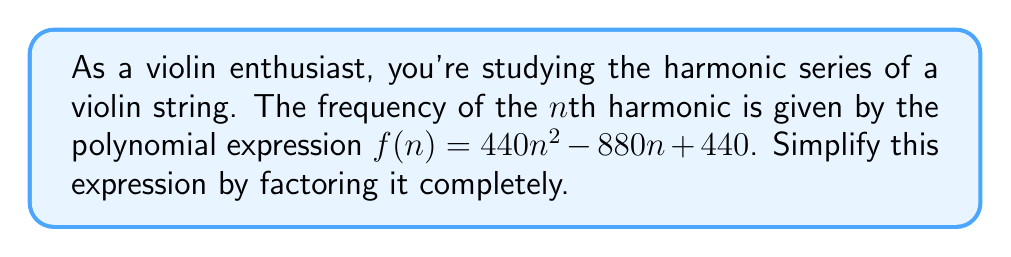Can you answer this question? Let's approach this step-by-step:

1) First, we recognize that this is a quadratic expression in the form $an^2 + bn + c$, where:
   $a = 440$
   $b = -880$
   $c = 440$

2) To factor this, we'll use the common factor method first:
   $f(n) = 440(n^2 - 2n + 1)$

3) Now, we focus on the expression inside the parentheses: $n^2 - 2n + 1$
   This is a perfect square trinomial in the form $(n - 1)^2$

4) Therefore, we can rewrite our expression as:
   $f(n) = 440(n - 1)^2$

5) This is now fully factored. We can interpret this musically:
   - 440 Hz is the frequency of A4 (the A above middle C)
   - $(n - 1)^2$ represents how the frequency changes for each harmonic

This simplified form shows that the frequency of each harmonic is proportional to the square of its position in the series, shifted by 1, and scaled by the fundamental frequency (440 Hz).
Answer: $f(n) = 440(n - 1)^2$ 